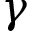<formula> <loc_0><loc_0><loc_500><loc_500>\gamma</formula> 